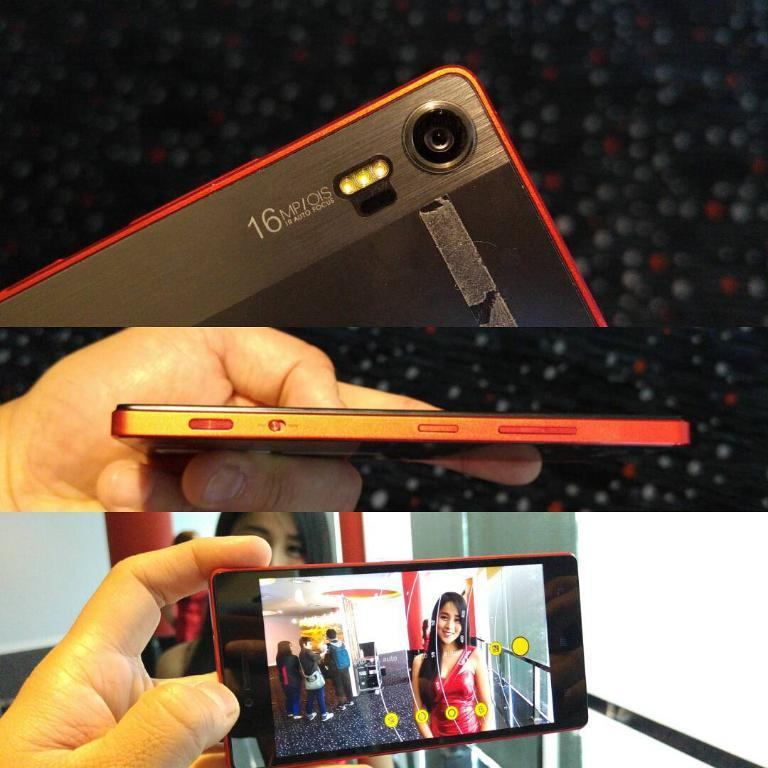<image>
Provide a brief description of the given image. A red and black phone that as a  16 MP/OIS camera. 